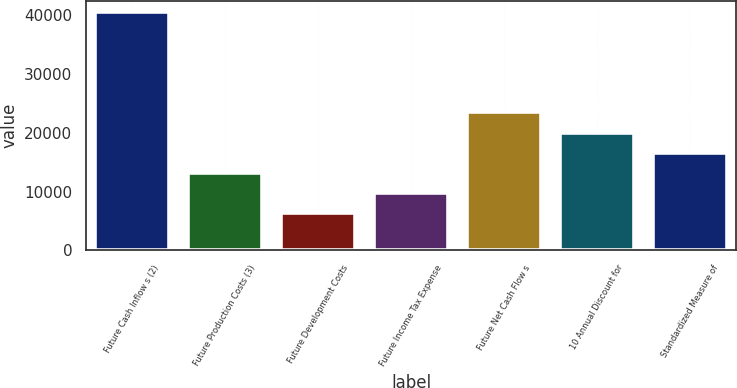Convert chart. <chart><loc_0><loc_0><loc_500><loc_500><bar_chart><fcel>Future Cash Inflow s (2)<fcel>Future Production Costs (3)<fcel>Future Development Costs<fcel>Future Income Tax Expense<fcel>Future Net Cash Flow s<fcel>10 Annual Discount for<fcel>Standardized Measure of<nl><fcel>40517<fcel>13237<fcel>6417<fcel>9827<fcel>23467<fcel>20057<fcel>16647<nl></chart> 